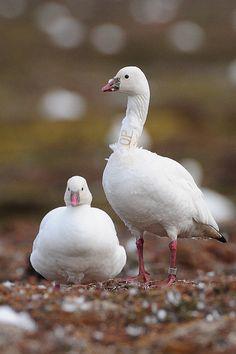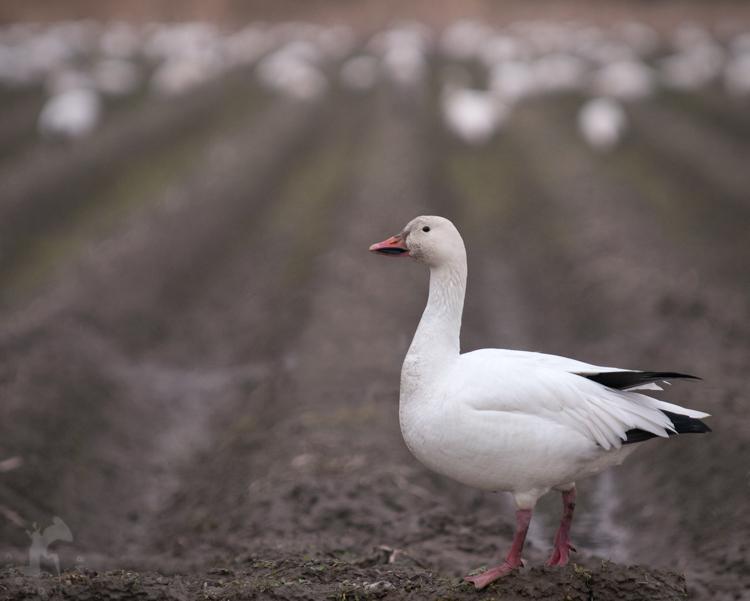The first image is the image on the left, the second image is the image on the right. Given the left and right images, does the statement "All the geese have completely white heads." hold true? Answer yes or no. Yes. 